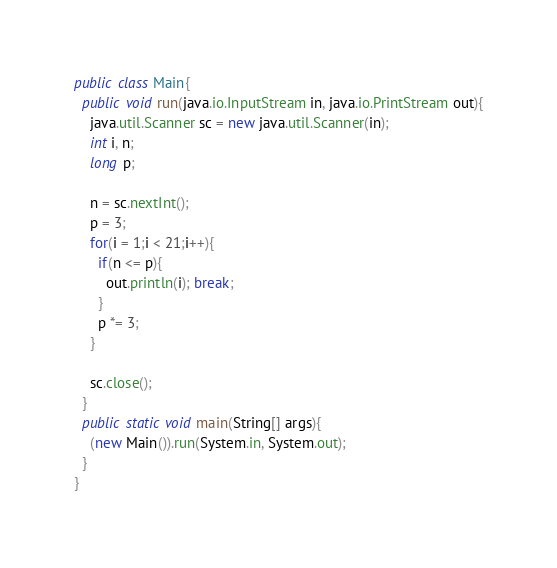Convert code to text. <code><loc_0><loc_0><loc_500><loc_500><_Java_>public class Main{
  public void run(java.io.InputStream in, java.io.PrintStream out){
    java.util.Scanner sc = new java.util.Scanner(in);
    int i, n;
    long p;

    n = sc.nextInt();
    p = 3;
    for(i = 1;i < 21;i++){
      if(n <= p){
        out.println(i); break;
      }
      p *= 3;
    }

    sc.close();
  }
  public static void main(String[] args){
    (new Main()).run(System.in, System.out);
  }
}</code> 